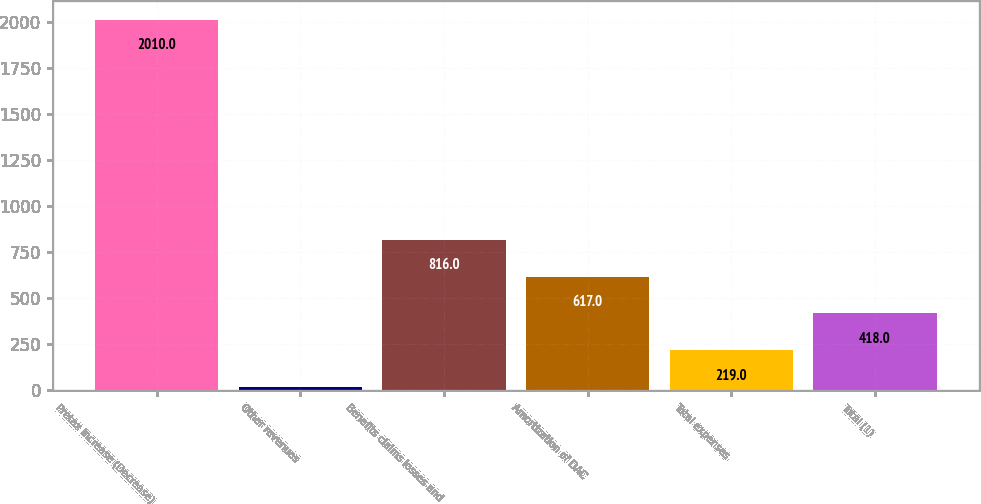<chart> <loc_0><loc_0><loc_500><loc_500><bar_chart><fcel>Pretax Increase (Decrease)<fcel>Other revenues<fcel>Benefits claims losses and<fcel>Amortization of DAC<fcel>Total expenses<fcel>Total (1)<nl><fcel>2010<fcel>20<fcel>816<fcel>617<fcel>219<fcel>418<nl></chart> 